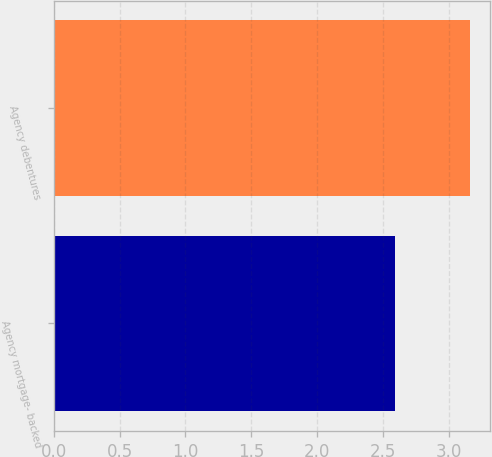Convert chart to OTSL. <chart><loc_0><loc_0><loc_500><loc_500><bar_chart><fcel>Agency mortgage- backed<fcel>Agency debentures<nl><fcel>2.59<fcel>3.16<nl></chart> 